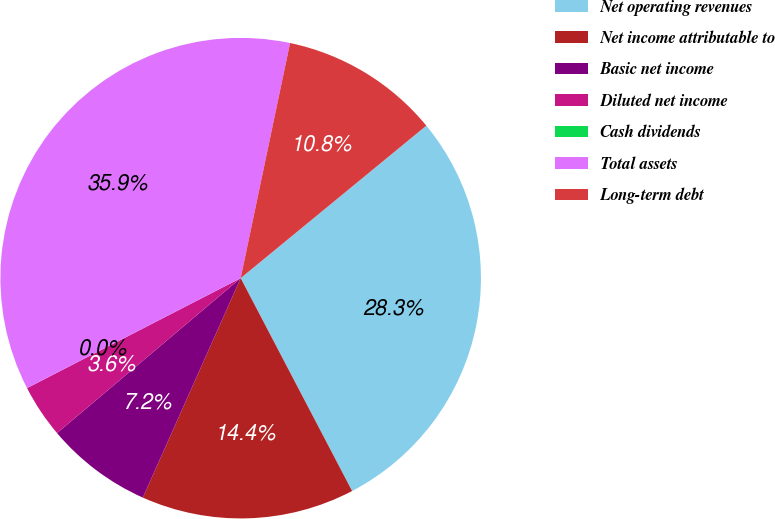Convert chart to OTSL. <chart><loc_0><loc_0><loc_500><loc_500><pie_chart><fcel>Net operating revenues<fcel>Net income attributable to<fcel>Basic net income<fcel>Diluted net income<fcel>Cash dividends<fcel>Total assets<fcel>Long-term debt<nl><fcel>28.27%<fcel>14.35%<fcel>7.17%<fcel>3.59%<fcel>0.0%<fcel>35.86%<fcel>10.76%<nl></chart> 